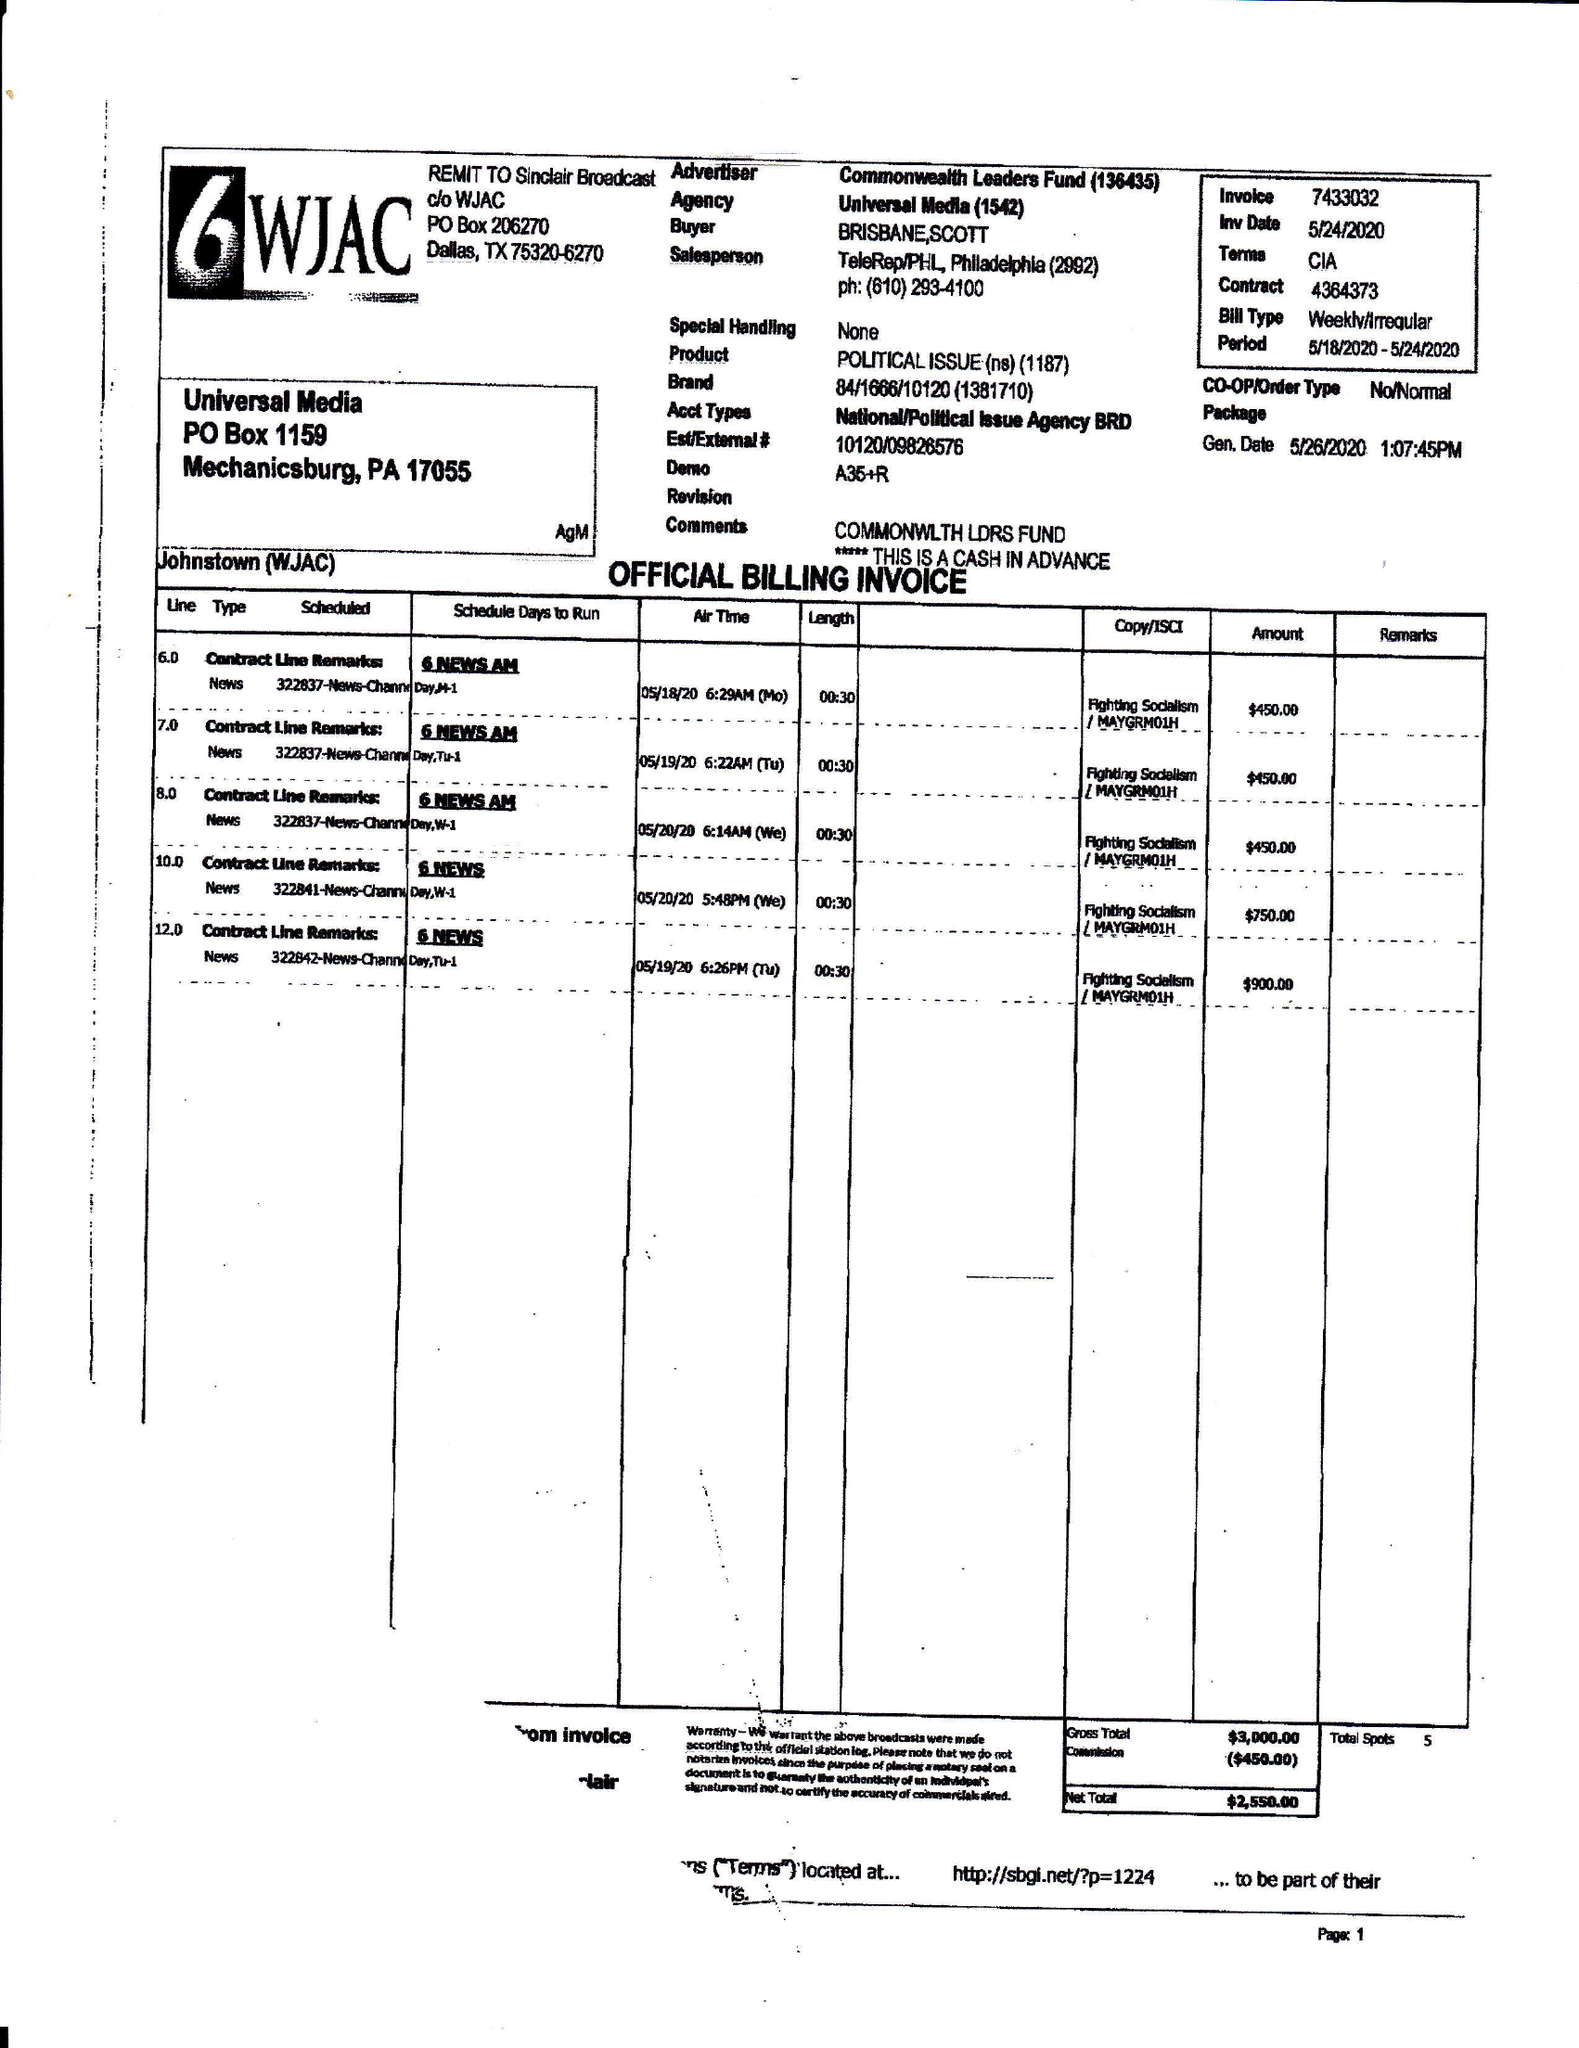What is the value for the flight_to?
Answer the question using a single word or phrase. 05/24/20 